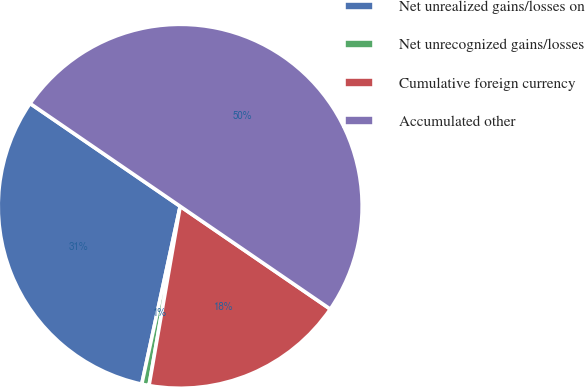Convert chart to OTSL. <chart><loc_0><loc_0><loc_500><loc_500><pie_chart><fcel>Net unrealized gains/losses on<fcel>Net unrecognized gains/losses<fcel>Cumulative foreign currency<fcel>Accumulated other<nl><fcel>31.17%<fcel>0.65%<fcel>18.18%<fcel>50.0%<nl></chart> 